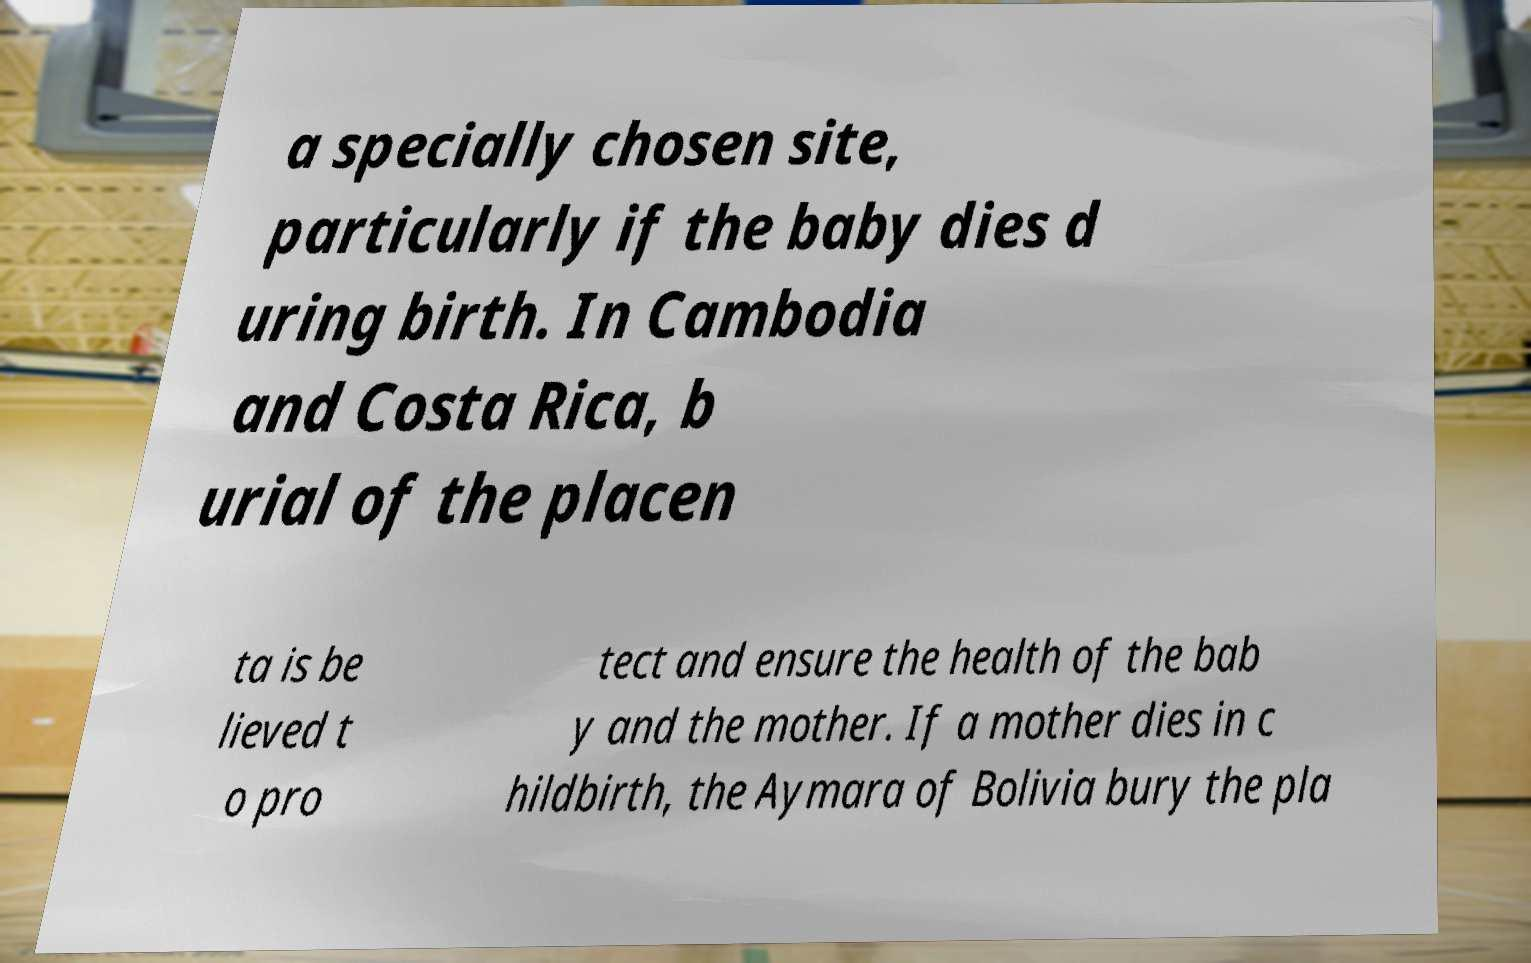Please read and relay the text visible in this image. What does it say? a specially chosen site, particularly if the baby dies d uring birth. In Cambodia and Costa Rica, b urial of the placen ta is be lieved t o pro tect and ensure the health of the bab y and the mother. If a mother dies in c hildbirth, the Aymara of Bolivia bury the pla 